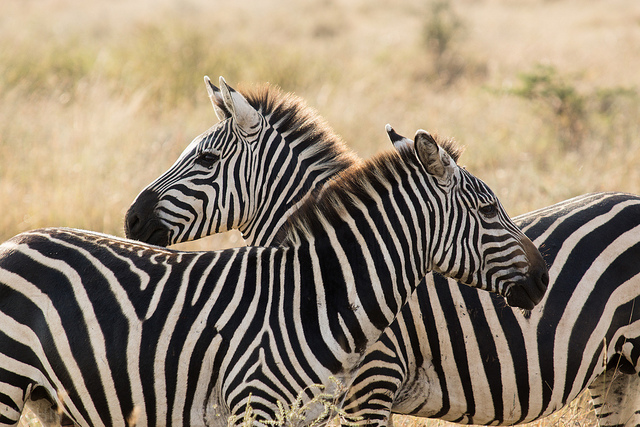What might the zebras be thinking? If we could guess the thoughts of these zebras, they might be contemplating the safety of their current location while also remaining attentive to any cues from their environment signaling the presence of food or danger. Zebras rely on both their instincts and their social bonds to navigate the complexities of their habitat. Imagine a magical interaction involving these zebras. As the sun sets and the savannah is bathed in twilight, the two zebras suddenly find themselves in a world transformed by magic. Stars begin to twinkle not only in the sky but also in the grass around them, creating a celestial carpet. The zebras, now glowing with a gentle luminescence, discover they have the ability to speak with the other animals. They converse with wise elephants and spirited antelopes, forming alliances and sharing stories as they prepare for the adventure of exploring this enchanted African night. Could these zebras be communicating in any way? Zebras communicate through a variety of vocalizations, body postures, and movements. The positioning of their ears, the swishing of their tails, and specific calls can all convey different messages to each other. For instance, a zebra might bray to signal alarm or snort to indicate irritation or a mild threat. Describe a short scenario where these zebras are interacting with another species. In the mid-morning sun, a pair of zebras encounters a group of curious meerkats. The meerkats stand on their hind legs, scanning the horizon, while the zebras continue grazing but keep an eye on the small mammals. Occasionally, the zebras and meerkats meet eyes in a silent understanding of coexistence in the vast stretch of the savannah. 